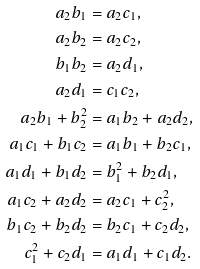Convert formula to latex. <formula><loc_0><loc_0><loc_500><loc_500>a _ { 2 } b _ { 1 } & = a _ { 2 } c _ { 1 } , \\ a _ { 2 } b _ { 2 } & = a _ { 2 } c _ { 2 } , \\ b _ { 1 } b _ { 2 } & = a _ { 2 } d _ { 1 } , \\ a _ { 2 } d _ { 1 } & = c _ { 1 } c _ { 2 } , \\ a _ { 2 } b _ { 1 } + b _ { 2 } ^ { 2 } & = a _ { 1 } b _ { 2 } + a _ { 2 } d _ { 2 } , \\ a _ { 1 } c _ { 1 } + b _ { 1 } c _ { 2 } & = a _ { 1 } b _ { 1 } + b _ { 2 } c _ { 1 } , \\ a _ { 1 } d _ { 1 } + b _ { 1 } d _ { 2 } & = b _ { 1 } ^ { 2 } + b _ { 2 } d _ { 1 } , \\ a _ { 1 } c _ { 2 } + a _ { 2 } d _ { 2 } & = a _ { 2 } c _ { 1 } + c _ { 2 } ^ { 2 } , \\ b _ { 1 } c _ { 2 } + b _ { 2 } d _ { 2 } & = b _ { 2 } c _ { 1 } + c _ { 2 } d _ { 2 } , \\ c _ { 1 } ^ { 2 } + c _ { 2 } d _ { 1 } & = a _ { 1 } d _ { 1 } + c _ { 1 } d _ { 2 } .</formula> 